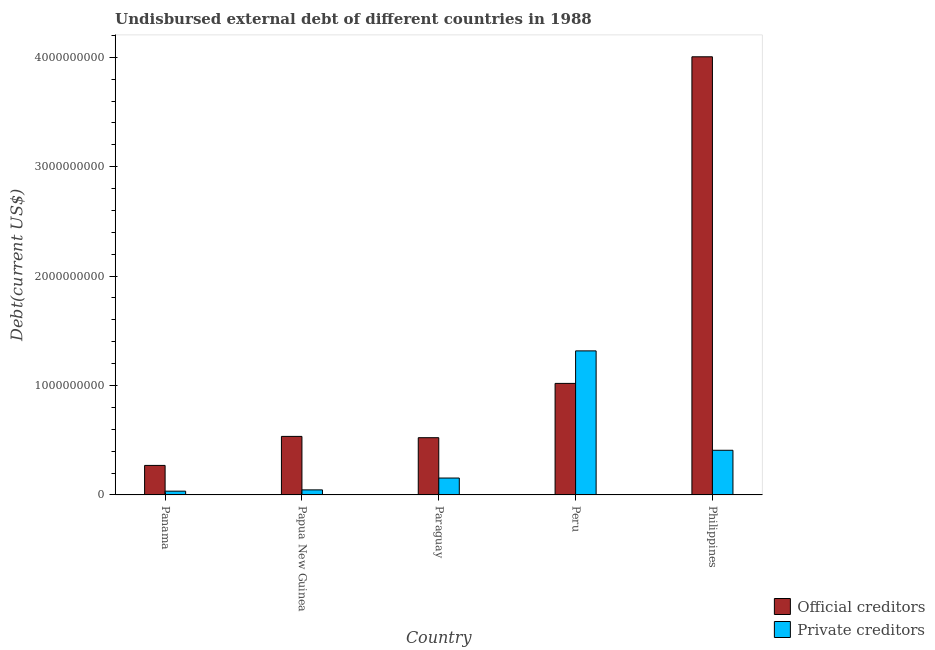How many different coloured bars are there?
Keep it short and to the point. 2. Are the number of bars on each tick of the X-axis equal?
Your answer should be very brief. Yes. How many bars are there on the 5th tick from the left?
Offer a terse response. 2. How many bars are there on the 1st tick from the right?
Give a very brief answer. 2. What is the label of the 2nd group of bars from the left?
Offer a very short reply. Papua New Guinea. What is the undisbursed external debt of official creditors in Paraguay?
Offer a very short reply. 5.23e+08. Across all countries, what is the maximum undisbursed external debt of official creditors?
Your answer should be compact. 4.00e+09. Across all countries, what is the minimum undisbursed external debt of official creditors?
Offer a terse response. 2.70e+08. In which country was the undisbursed external debt of official creditors maximum?
Provide a short and direct response. Philippines. In which country was the undisbursed external debt of private creditors minimum?
Your answer should be very brief. Panama. What is the total undisbursed external debt of private creditors in the graph?
Provide a short and direct response. 1.96e+09. What is the difference between the undisbursed external debt of official creditors in Papua New Guinea and that in Peru?
Provide a short and direct response. -4.84e+08. What is the difference between the undisbursed external debt of official creditors in Peru and the undisbursed external debt of private creditors in Philippines?
Give a very brief answer. 6.11e+08. What is the average undisbursed external debt of private creditors per country?
Give a very brief answer. 3.92e+08. What is the difference between the undisbursed external debt of private creditors and undisbursed external debt of official creditors in Philippines?
Your answer should be very brief. -3.60e+09. What is the ratio of the undisbursed external debt of private creditors in Papua New Guinea to that in Philippines?
Your answer should be very brief. 0.11. Is the undisbursed external debt of private creditors in Peru less than that in Philippines?
Give a very brief answer. No. Is the difference between the undisbursed external debt of official creditors in Panama and Philippines greater than the difference between the undisbursed external debt of private creditors in Panama and Philippines?
Ensure brevity in your answer.  No. What is the difference between the highest and the second highest undisbursed external debt of official creditors?
Provide a short and direct response. 2.98e+09. What is the difference between the highest and the lowest undisbursed external debt of official creditors?
Offer a very short reply. 3.73e+09. In how many countries, is the undisbursed external debt of private creditors greater than the average undisbursed external debt of private creditors taken over all countries?
Your answer should be compact. 2. What does the 1st bar from the left in Peru represents?
Offer a very short reply. Official creditors. What does the 1st bar from the right in Papua New Guinea represents?
Offer a terse response. Private creditors. How many bars are there?
Provide a succinct answer. 10. Are the values on the major ticks of Y-axis written in scientific E-notation?
Your answer should be compact. No. Does the graph contain any zero values?
Provide a short and direct response. No. Where does the legend appear in the graph?
Offer a very short reply. Bottom right. How many legend labels are there?
Offer a very short reply. 2. What is the title of the graph?
Provide a succinct answer. Undisbursed external debt of different countries in 1988. What is the label or title of the X-axis?
Your answer should be compact. Country. What is the label or title of the Y-axis?
Ensure brevity in your answer.  Debt(current US$). What is the Debt(current US$) of Official creditors in Panama?
Make the answer very short. 2.70e+08. What is the Debt(current US$) of Private creditors in Panama?
Keep it short and to the point. 3.45e+07. What is the Debt(current US$) of Official creditors in Papua New Guinea?
Ensure brevity in your answer.  5.35e+08. What is the Debt(current US$) of Private creditors in Papua New Guinea?
Give a very brief answer. 4.62e+07. What is the Debt(current US$) of Official creditors in Paraguay?
Offer a terse response. 5.23e+08. What is the Debt(current US$) of Private creditors in Paraguay?
Your response must be concise. 1.54e+08. What is the Debt(current US$) of Official creditors in Peru?
Your response must be concise. 1.02e+09. What is the Debt(current US$) in Private creditors in Peru?
Offer a very short reply. 1.32e+09. What is the Debt(current US$) of Official creditors in Philippines?
Offer a terse response. 4.00e+09. What is the Debt(current US$) in Private creditors in Philippines?
Provide a succinct answer. 4.08e+08. Across all countries, what is the maximum Debt(current US$) in Official creditors?
Provide a short and direct response. 4.00e+09. Across all countries, what is the maximum Debt(current US$) in Private creditors?
Offer a terse response. 1.32e+09. Across all countries, what is the minimum Debt(current US$) of Official creditors?
Make the answer very short. 2.70e+08. Across all countries, what is the minimum Debt(current US$) in Private creditors?
Your answer should be very brief. 3.45e+07. What is the total Debt(current US$) of Official creditors in the graph?
Provide a succinct answer. 6.35e+09. What is the total Debt(current US$) of Private creditors in the graph?
Your response must be concise. 1.96e+09. What is the difference between the Debt(current US$) in Official creditors in Panama and that in Papua New Guinea?
Make the answer very short. -2.65e+08. What is the difference between the Debt(current US$) in Private creditors in Panama and that in Papua New Guinea?
Offer a very short reply. -1.17e+07. What is the difference between the Debt(current US$) in Official creditors in Panama and that in Paraguay?
Your answer should be compact. -2.53e+08. What is the difference between the Debt(current US$) of Private creditors in Panama and that in Paraguay?
Make the answer very short. -1.20e+08. What is the difference between the Debt(current US$) in Official creditors in Panama and that in Peru?
Your answer should be compact. -7.50e+08. What is the difference between the Debt(current US$) in Private creditors in Panama and that in Peru?
Your answer should be very brief. -1.28e+09. What is the difference between the Debt(current US$) in Official creditors in Panama and that in Philippines?
Keep it short and to the point. -3.73e+09. What is the difference between the Debt(current US$) of Private creditors in Panama and that in Philippines?
Your answer should be compact. -3.74e+08. What is the difference between the Debt(current US$) of Official creditors in Papua New Guinea and that in Paraguay?
Your answer should be very brief. 1.19e+07. What is the difference between the Debt(current US$) in Private creditors in Papua New Guinea and that in Paraguay?
Provide a succinct answer. -1.08e+08. What is the difference between the Debt(current US$) in Official creditors in Papua New Guinea and that in Peru?
Your response must be concise. -4.84e+08. What is the difference between the Debt(current US$) of Private creditors in Papua New Guinea and that in Peru?
Your response must be concise. -1.27e+09. What is the difference between the Debt(current US$) of Official creditors in Papua New Guinea and that in Philippines?
Ensure brevity in your answer.  -3.47e+09. What is the difference between the Debt(current US$) in Private creditors in Papua New Guinea and that in Philippines?
Your answer should be compact. -3.62e+08. What is the difference between the Debt(current US$) of Official creditors in Paraguay and that in Peru?
Your answer should be very brief. -4.96e+08. What is the difference between the Debt(current US$) of Private creditors in Paraguay and that in Peru?
Make the answer very short. -1.16e+09. What is the difference between the Debt(current US$) in Official creditors in Paraguay and that in Philippines?
Your response must be concise. -3.48e+09. What is the difference between the Debt(current US$) of Private creditors in Paraguay and that in Philippines?
Ensure brevity in your answer.  -2.54e+08. What is the difference between the Debt(current US$) in Official creditors in Peru and that in Philippines?
Your answer should be very brief. -2.98e+09. What is the difference between the Debt(current US$) of Private creditors in Peru and that in Philippines?
Offer a very short reply. 9.08e+08. What is the difference between the Debt(current US$) in Official creditors in Panama and the Debt(current US$) in Private creditors in Papua New Guinea?
Ensure brevity in your answer.  2.24e+08. What is the difference between the Debt(current US$) of Official creditors in Panama and the Debt(current US$) of Private creditors in Paraguay?
Your response must be concise. 1.15e+08. What is the difference between the Debt(current US$) of Official creditors in Panama and the Debt(current US$) of Private creditors in Peru?
Offer a terse response. -1.05e+09. What is the difference between the Debt(current US$) of Official creditors in Panama and the Debt(current US$) of Private creditors in Philippines?
Give a very brief answer. -1.38e+08. What is the difference between the Debt(current US$) of Official creditors in Papua New Guinea and the Debt(current US$) of Private creditors in Paraguay?
Provide a short and direct response. 3.80e+08. What is the difference between the Debt(current US$) in Official creditors in Papua New Guinea and the Debt(current US$) in Private creditors in Peru?
Provide a succinct answer. -7.81e+08. What is the difference between the Debt(current US$) of Official creditors in Papua New Guinea and the Debt(current US$) of Private creditors in Philippines?
Give a very brief answer. 1.27e+08. What is the difference between the Debt(current US$) of Official creditors in Paraguay and the Debt(current US$) of Private creditors in Peru?
Keep it short and to the point. -7.93e+08. What is the difference between the Debt(current US$) in Official creditors in Paraguay and the Debt(current US$) in Private creditors in Philippines?
Provide a succinct answer. 1.15e+08. What is the difference between the Debt(current US$) in Official creditors in Peru and the Debt(current US$) in Private creditors in Philippines?
Your answer should be very brief. 6.11e+08. What is the average Debt(current US$) of Official creditors per country?
Provide a short and direct response. 1.27e+09. What is the average Debt(current US$) of Private creditors per country?
Provide a succinct answer. 3.92e+08. What is the difference between the Debt(current US$) in Official creditors and Debt(current US$) in Private creditors in Panama?
Give a very brief answer. 2.35e+08. What is the difference between the Debt(current US$) in Official creditors and Debt(current US$) in Private creditors in Papua New Guinea?
Your answer should be compact. 4.89e+08. What is the difference between the Debt(current US$) of Official creditors and Debt(current US$) of Private creditors in Paraguay?
Keep it short and to the point. 3.69e+08. What is the difference between the Debt(current US$) in Official creditors and Debt(current US$) in Private creditors in Peru?
Your answer should be very brief. -2.97e+08. What is the difference between the Debt(current US$) in Official creditors and Debt(current US$) in Private creditors in Philippines?
Ensure brevity in your answer.  3.60e+09. What is the ratio of the Debt(current US$) of Official creditors in Panama to that in Papua New Guinea?
Keep it short and to the point. 0.5. What is the ratio of the Debt(current US$) of Private creditors in Panama to that in Papua New Guinea?
Ensure brevity in your answer.  0.75. What is the ratio of the Debt(current US$) of Official creditors in Panama to that in Paraguay?
Your response must be concise. 0.52. What is the ratio of the Debt(current US$) in Private creditors in Panama to that in Paraguay?
Ensure brevity in your answer.  0.22. What is the ratio of the Debt(current US$) of Official creditors in Panama to that in Peru?
Your answer should be very brief. 0.26. What is the ratio of the Debt(current US$) of Private creditors in Panama to that in Peru?
Your answer should be very brief. 0.03. What is the ratio of the Debt(current US$) of Official creditors in Panama to that in Philippines?
Keep it short and to the point. 0.07. What is the ratio of the Debt(current US$) in Private creditors in Panama to that in Philippines?
Provide a short and direct response. 0.08. What is the ratio of the Debt(current US$) in Official creditors in Papua New Guinea to that in Paraguay?
Your answer should be compact. 1.02. What is the ratio of the Debt(current US$) in Private creditors in Papua New Guinea to that in Paraguay?
Provide a succinct answer. 0.3. What is the ratio of the Debt(current US$) of Official creditors in Papua New Guinea to that in Peru?
Keep it short and to the point. 0.52. What is the ratio of the Debt(current US$) in Private creditors in Papua New Guinea to that in Peru?
Offer a very short reply. 0.04. What is the ratio of the Debt(current US$) in Official creditors in Papua New Guinea to that in Philippines?
Provide a succinct answer. 0.13. What is the ratio of the Debt(current US$) of Private creditors in Papua New Guinea to that in Philippines?
Your answer should be compact. 0.11. What is the ratio of the Debt(current US$) in Official creditors in Paraguay to that in Peru?
Offer a terse response. 0.51. What is the ratio of the Debt(current US$) of Private creditors in Paraguay to that in Peru?
Your answer should be very brief. 0.12. What is the ratio of the Debt(current US$) of Official creditors in Paraguay to that in Philippines?
Provide a short and direct response. 0.13. What is the ratio of the Debt(current US$) of Private creditors in Paraguay to that in Philippines?
Your response must be concise. 0.38. What is the ratio of the Debt(current US$) in Official creditors in Peru to that in Philippines?
Give a very brief answer. 0.25. What is the ratio of the Debt(current US$) of Private creditors in Peru to that in Philippines?
Make the answer very short. 3.23. What is the difference between the highest and the second highest Debt(current US$) of Official creditors?
Give a very brief answer. 2.98e+09. What is the difference between the highest and the second highest Debt(current US$) in Private creditors?
Your answer should be very brief. 9.08e+08. What is the difference between the highest and the lowest Debt(current US$) of Official creditors?
Provide a succinct answer. 3.73e+09. What is the difference between the highest and the lowest Debt(current US$) of Private creditors?
Your response must be concise. 1.28e+09. 